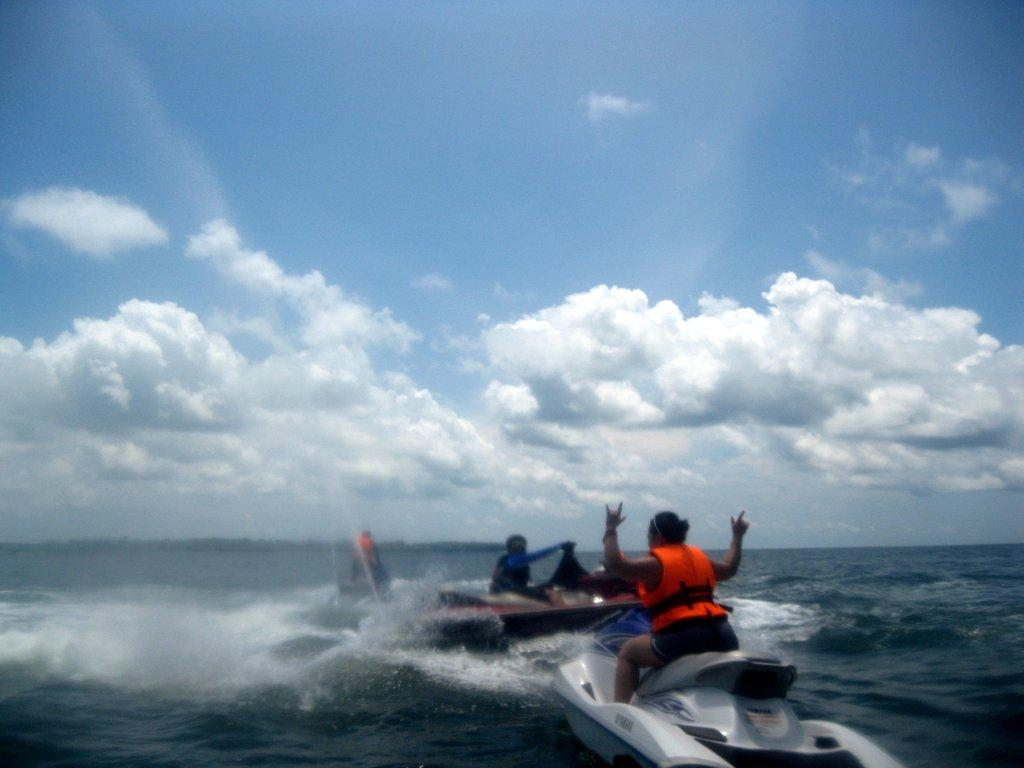How many people are in the image? There are two persons in the image. What are the persons doing in the image? The persons are riding speed boats. What is visible at the bottom of the image? There is water visible at the bottom of the image. What safety equipment are the persons wearing? The person(s) is/are wearing a life jacket. What is visible at the top of the image? The sky is visible at the top of the image. What color is the knife used by the person in the image? There is no knife present in the image; the persons are riding speed boats in water. 